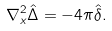<formula> <loc_0><loc_0><loc_500><loc_500>\nabla ^ { 2 } _ { x } \hat { \Delta } = - 4 \pi \hat { \delta } .</formula> 